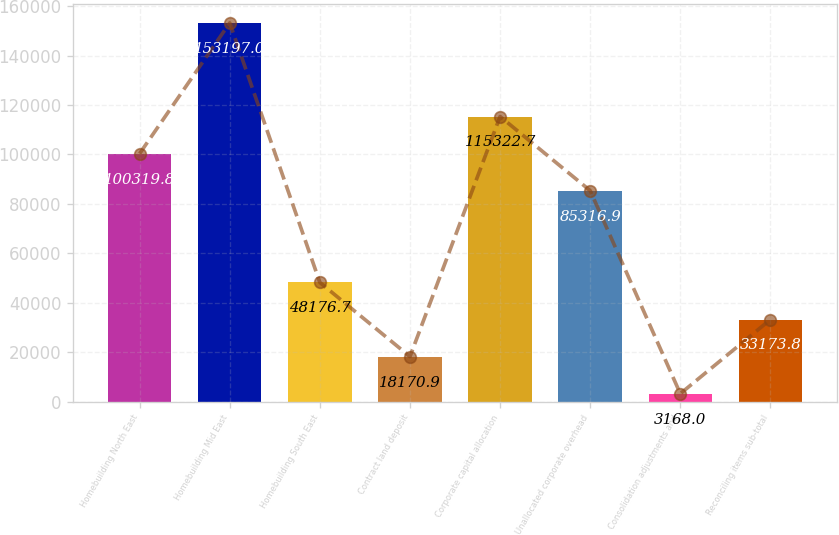<chart> <loc_0><loc_0><loc_500><loc_500><bar_chart><fcel>Homebuilding North East<fcel>Homebuilding Mid East<fcel>Homebuilding South East<fcel>Contract land deposit<fcel>Corporate capital allocation<fcel>Unallocated corporate overhead<fcel>Consolidation adjustments and<fcel>Reconciling items sub-total<nl><fcel>100320<fcel>153197<fcel>48176.7<fcel>18170.9<fcel>115323<fcel>85316.9<fcel>3168<fcel>33173.8<nl></chart> 